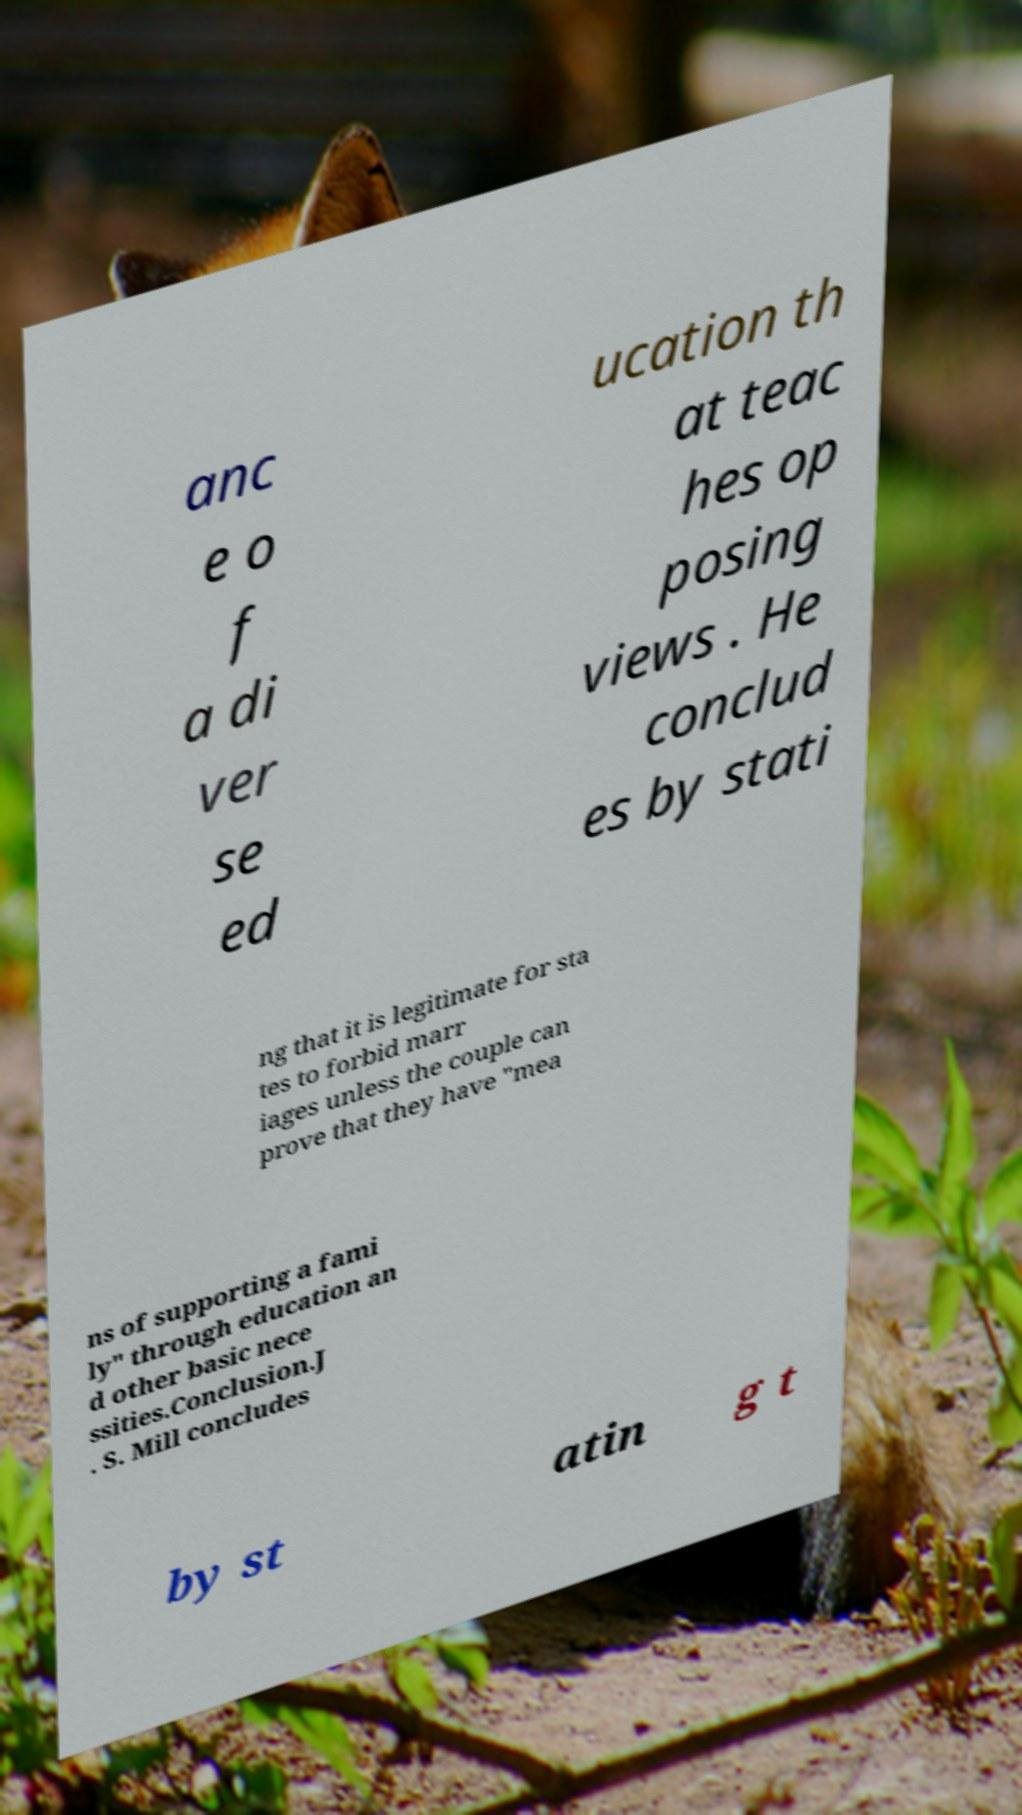I need the written content from this picture converted into text. Can you do that? anc e o f a di ver se ed ucation th at teac hes op posing views . He conclud es by stati ng that it is legitimate for sta tes to forbid marr iages unless the couple can prove that they have "mea ns of supporting a fami ly" through education an d other basic nece ssities.Conclusion.J . S. Mill concludes by st atin g t 